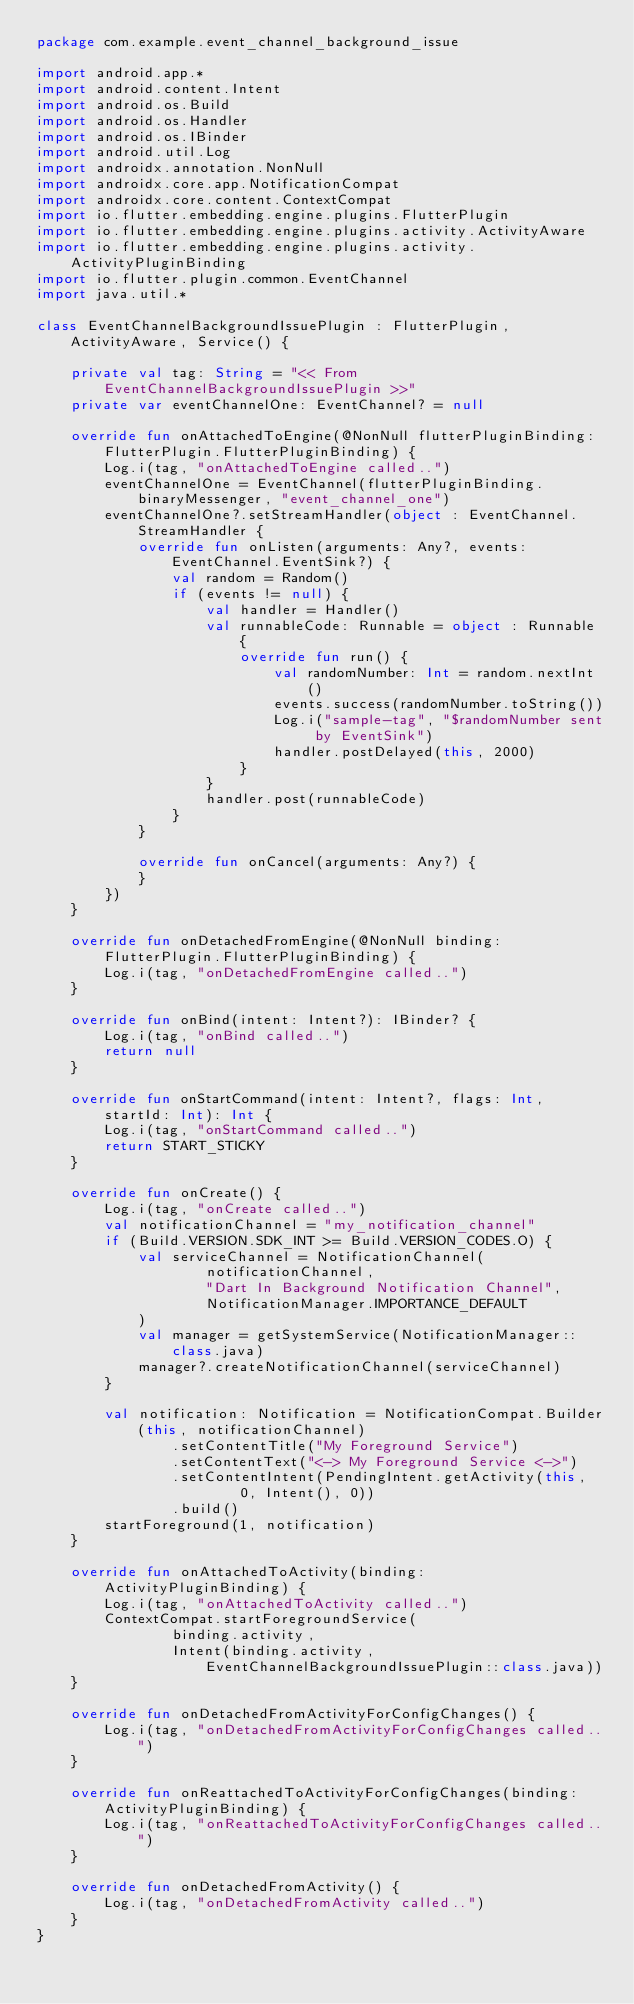<code> <loc_0><loc_0><loc_500><loc_500><_Kotlin_>package com.example.event_channel_background_issue

import android.app.*
import android.content.Intent
import android.os.Build
import android.os.Handler
import android.os.IBinder
import android.util.Log
import androidx.annotation.NonNull
import androidx.core.app.NotificationCompat
import androidx.core.content.ContextCompat
import io.flutter.embedding.engine.plugins.FlutterPlugin
import io.flutter.embedding.engine.plugins.activity.ActivityAware
import io.flutter.embedding.engine.plugins.activity.ActivityPluginBinding
import io.flutter.plugin.common.EventChannel
import java.util.*

class EventChannelBackgroundIssuePlugin : FlutterPlugin, ActivityAware, Service() {

    private val tag: String = "<< From EventChannelBackgroundIssuePlugin >>"
    private var eventChannelOne: EventChannel? = null

    override fun onAttachedToEngine(@NonNull flutterPluginBinding: FlutterPlugin.FlutterPluginBinding) {
        Log.i(tag, "onAttachedToEngine called..")
        eventChannelOne = EventChannel(flutterPluginBinding.binaryMessenger, "event_channel_one")
        eventChannelOne?.setStreamHandler(object : EventChannel.StreamHandler {
            override fun onListen(arguments: Any?, events: EventChannel.EventSink?) {
                val random = Random()
                if (events != null) {
                    val handler = Handler()
                    val runnableCode: Runnable = object : Runnable {
                        override fun run() {
                            val randomNumber: Int = random.nextInt()
                            events.success(randomNumber.toString())
                            Log.i("sample-tag", "$randomNumber sent by EventSink")
                            handler.postDelayed(this, 2000)
                        }
                    }
                    handler.post(runnableCode)
                }
            }

            override fun onCancel(arguments: Any?) {
            }
        })
    }

    override fun onDetachedFromEngine(@NonNull binding: FlutterPlugin.FlutterPluginBinding) {
        Log.i(tag, "onDetachedFromEngine called..")
    }

    override fun onBind(intent: Intent?): IBinder? {
        Log.i(tag, "onBind called..")
        return null
    }

    override fun onStartCommand(intent: Intent?, flags: Int, startId: Int): Int {
        Log.i(tag, "onStartCommand called..")
        return START_STICKY
    }

    override fun onCreate() {
        Log.i(tag, "onCreate called..")
        val notificationChannel = "my_notification_channel"
        if (Build.VERSION.SDK_INT >= Build.VERSION_CODES.O) {
            val serviceChannel = NotificationChannel(
                    notificationChannel,
                    "Dart In Background Notification Channel",
                    NotificationManager.IMPORTANCE_DEFAULT
            )
            val manager = getSystemService(NotificationManager::class.java)
            manager?.createNotificationChannel(serviceChannel)
        }

        val notification: Notification = NotificationCompat.Builder(this, notificationChannel)
                .setContentTitle("My Foreground Service")
                .setContentText("<-> My Foreground Service <->")
                .setContentIntent(PendingIntent.getActivity(this,
                        0, Intent(), 0))
                .build()
        startForeground(1, notification)
    }

    override fun onAttachedToActivity(binding: ActivityPluginBinding) {
        Log.i(tag, "onAttachedToActivity called..")
        ContextCompat.startForegroundService(
                binding.activity,
                Intent(binding.activity, EventChannelBackgroundIssuePlugin::class.java))
    }

    override fun onDetachedFromActivityForConfigChanges() {
        Log.i(tag, "onDetachedFromActivityForConfigChanges called..")
    }

    override fun onReattachedToActivityForConfigChanges(binding: ActivityPluginBinding) {
        Log.i(tag, "onReattachedToActivityForConfigChanges called..")
    }

    override fun onDetachedFromActivity() {
        Log.i(tag, "onDetachedFromActivity called..")
    }
}
</code> 